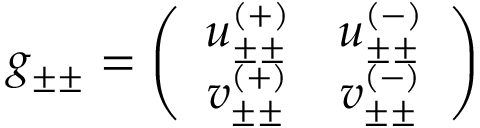Convert formula to latex. <formula><loc_0><loc_0><loc_500><loc_500>g _ { \pm \pm } = \left ( \begin{array} { c c } { { u _ { \pm \pm } ^ { ( + ) } } } & { { u _ { \pm \pm } ^ { ( - ) } } } \\ { { v _ { \pm \pm } ^ { ( + ) } } } & { { v _ { \pm \pm } ^ { ( - ) } } } \end{array} \right )</formula> 